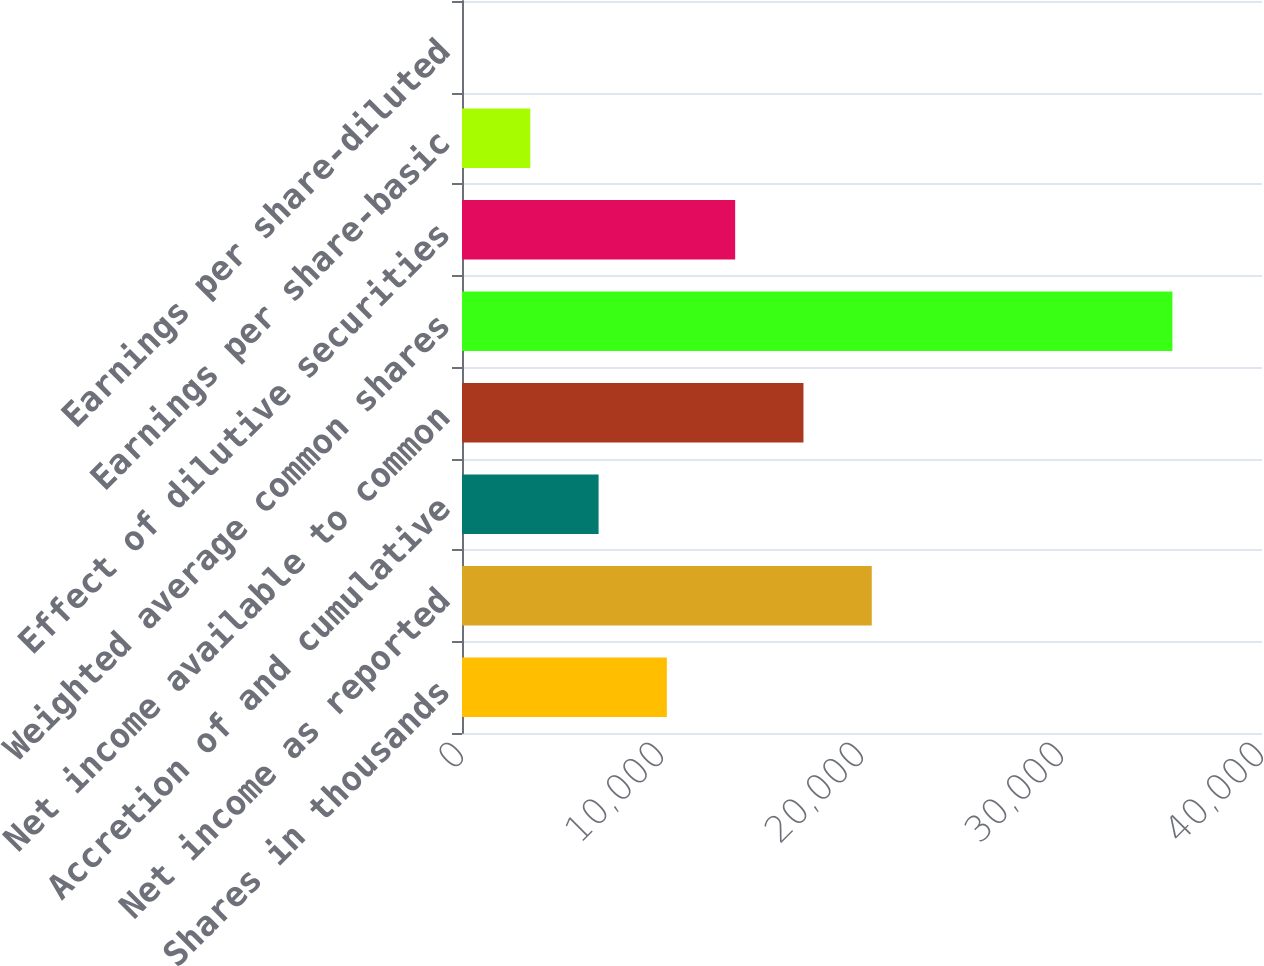Convert chart to OTSL. <chart><loc_0><loc_0><loc_500><loc_500><bar_chart><fcel>Shares in thousands<fcel>Net income as reported<fcel>Accretion of and cumulative<fcel>Net income available to common<fcel>Weighted average common shares<fcel>Effect of dilutive securities<fcel>Earnings per share-basic<fcel>Earnings per share-diluted<nl><fcel>10243.9<fcel>20487.7<fcel>6829.32<fcel>17073.1<fcel>35520.6<fcel>13658.5<fcel>3414.74<fcel>0.15<nl></chart> 